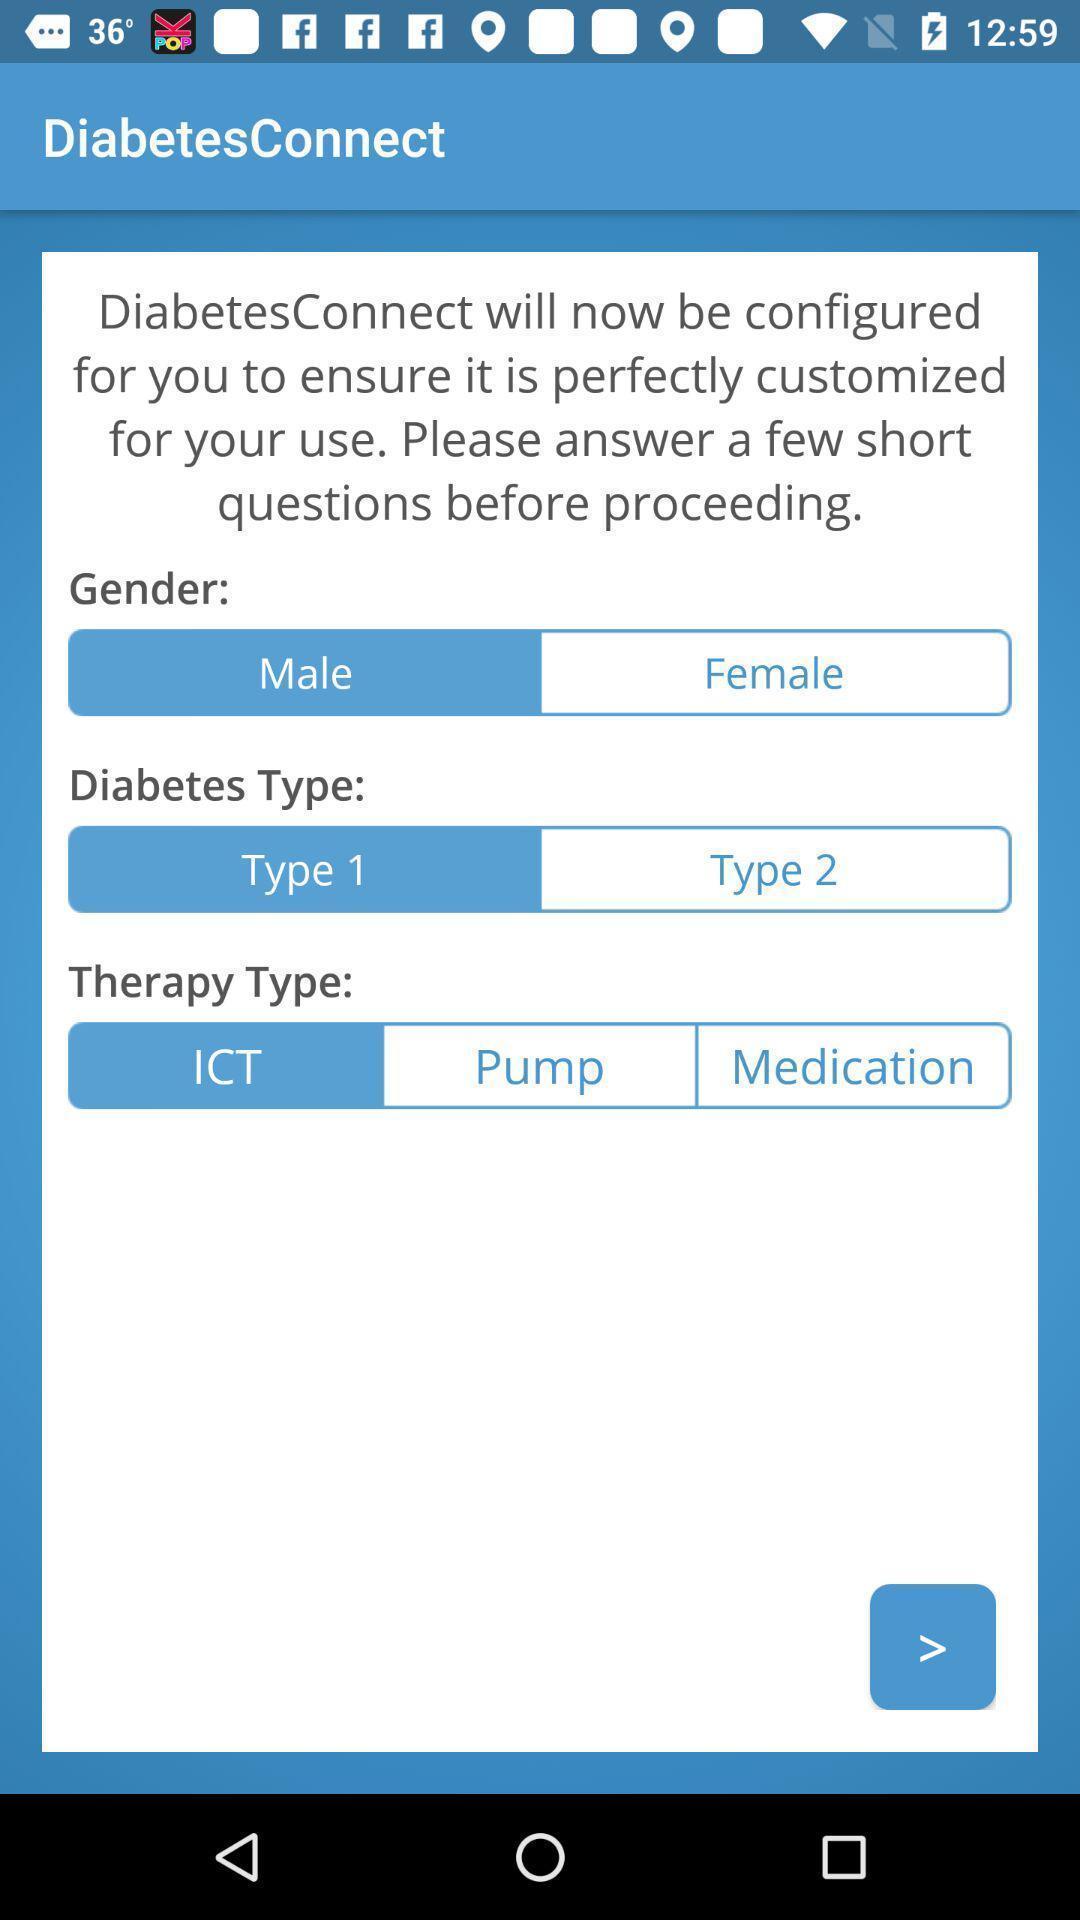Summarize the information in this screenshot. Screen displaying the page of a medical app. 